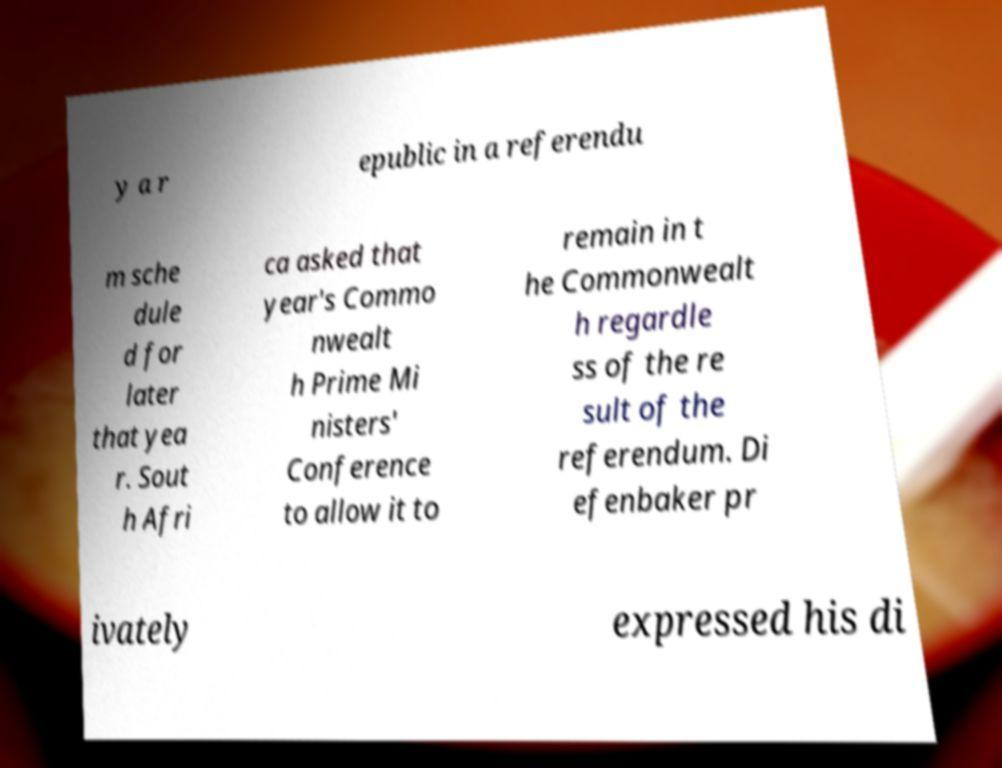Could you assist in decoding the text presented in this image and type it out clearly? y a r epublic in a referendu m sche dule d for later that yea r. Sout h Afri ca asked that year's Commo nwealt h Prime Mi nisters' Conference to allow it to remain in t he Commonwealt h regardle ss of the re sult of the referendum. Di efenbaker pr ivately expressed his di 